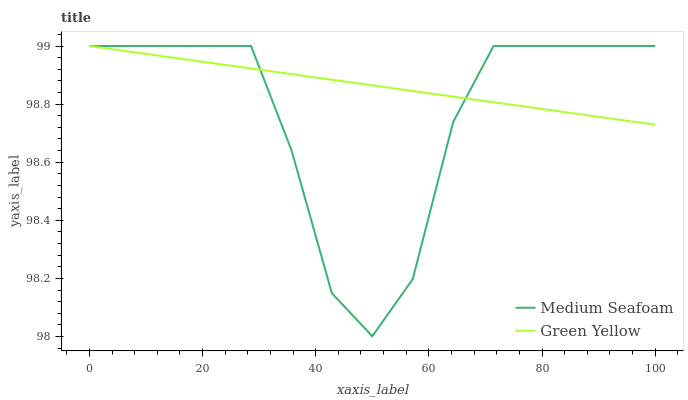Does Medium Seafoam have the minimum area under the curve?
Answer yes or no. Yes. Does Green Yellow have the maximum area under the curve?
Answer yes or no. Yes. Does Medium Seafoam have the maximum area under the curve?
Answer yes or no. No. Is Green Yellow the smoothest?
Answer yes or no. Yes. Is Medium Seafoam the roughest?
Answer yes or no. Yes. Is Medium Seafoam the smoothest?
Answer yes or no. No. Does Medium Seafoam have the lowest value?
Answer yes or no. Yes. Does Medium Seafoam have the highest value?
Answer yes or no. Yes. Does Medium Seafoam intersect Green Yellow?
Answer yes or no. Yes. Is Medium Seafoam less than Green Yellow?
Answer yes or no. No. Is Medium Seafoam greater than Green Yellow?
Answer yes or no. No. 